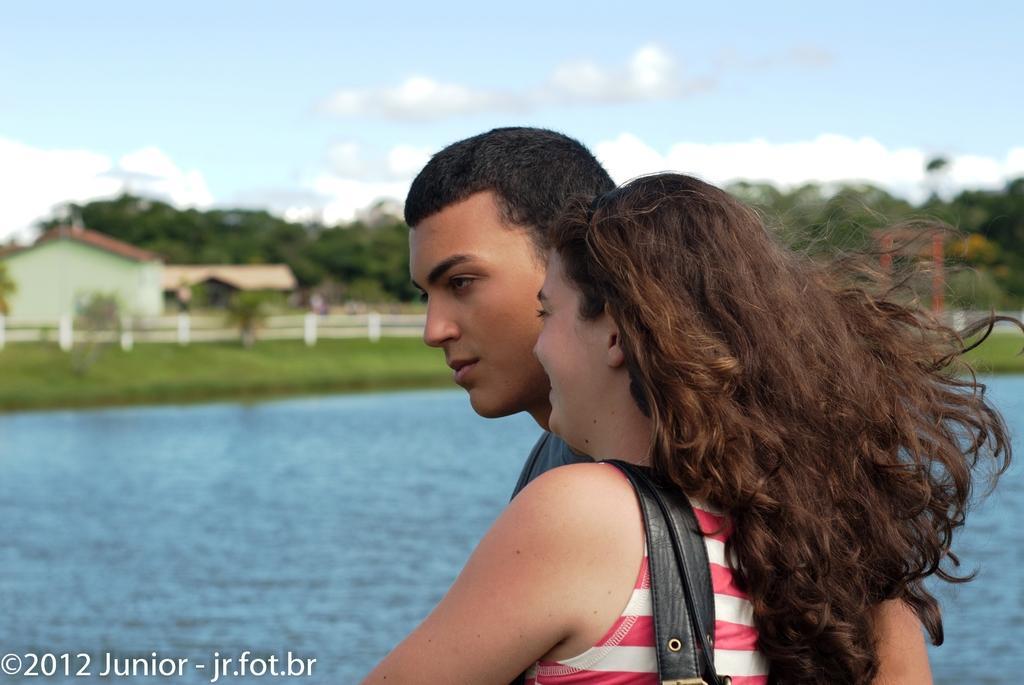How would you summarize this image in a sentence or two? In this image I can see two people with different color dresses. To the side of these people I can see the water. In the background I can see the railing, house, many trees, clouds and the sky. 